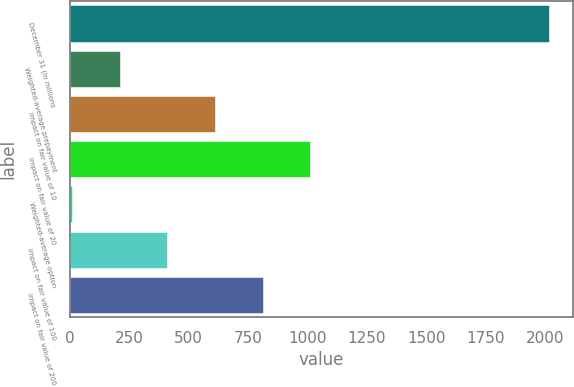Convert chart. <chart><loc_0><loc_0><loc_500><loc_500><bar_chart><fcel>December 31 (in millions<fcel>Weighted-average prepayment<fcel>Impact on fair value of 10<fcel>Impact on fair value of 20<fcel>Weighted-average option<fcel>Impact on fair value of 100<fcel>Impact on fair value of 200<nl><fcel>2015<fcel>210.09<fcel>611.19<fcel>1012.29<fcel>9.54<fcel>410.64<fcel>811.74<nl></chart> 